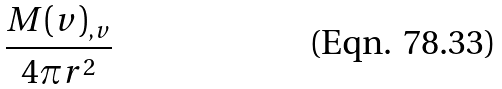Convert formula to latex. <formula><loc_0><loc_0><loc_500><loc_500>\frac { M ( v ) _ { , v } } { 4 \pi r ^ { 2 } }</formula> 